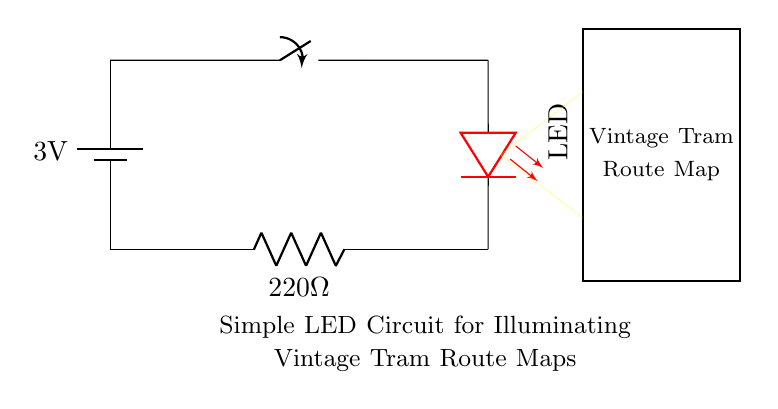What is the voltage of the battery? The diagram indicates the battery voltage as 3V, labeled next to the battery component.
Answer: 3V What component limits the current to the LED? The resistor is specified in the circuit as 220 Ohms, which is used to limit the current flowing to the LED to prevent it from burning out.
Answer: 220 Ohms What type of component is represented in the circuit for illuminating the tram map? The circuit contains an LED component, which is specifically designed to provide illumination when current flows through it.
Answer: LED How many components are directly connected to the battery? The battery is connected sequentially to the switch and then to the LED, which counts as two components besides itself.
Answer: Two What color is the LED in this circuit? The LED is indicated as red in the diagram, shown with a label specifying its color.
Answer: Red What happens when the switch is closed? When the switch is closed, it completes the circuit allowing current to flow from the battery through the LED and the resistor, thus illuminating the tram route map.
Answer: LED lights up What is the purpose of the yellow arrows in the diagram? The yellow arrows represent the light beam emitted by the LED, indicating the area that is illuminated by the LED when it is powered on.
Answer: Illumination area 